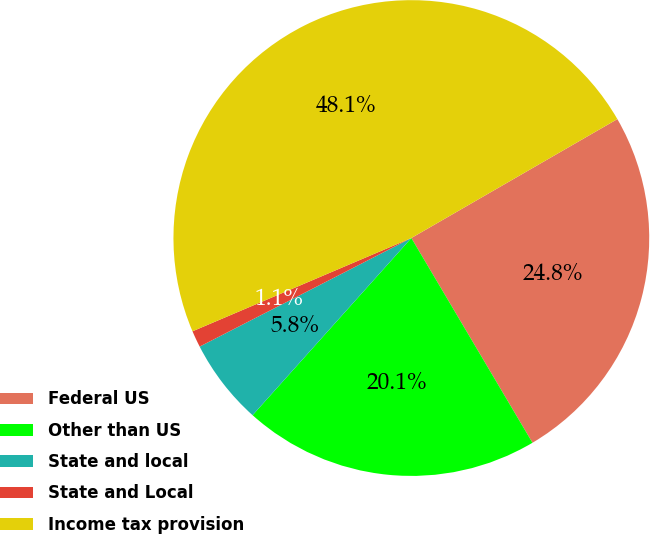Convert chart to OTSL. <chart><loc_0><loc_0><loc_500><loc_500><pie_chart><fcel>Federal US<fcel>Other than US<fcel>State and local<fcel>State and Local<fcel>Income tax provision<nl><fcel>24.83%<fcel>20.13%<fcel>5.83%<fcel>1.13%<fcel>48.08%<nl></chart> 